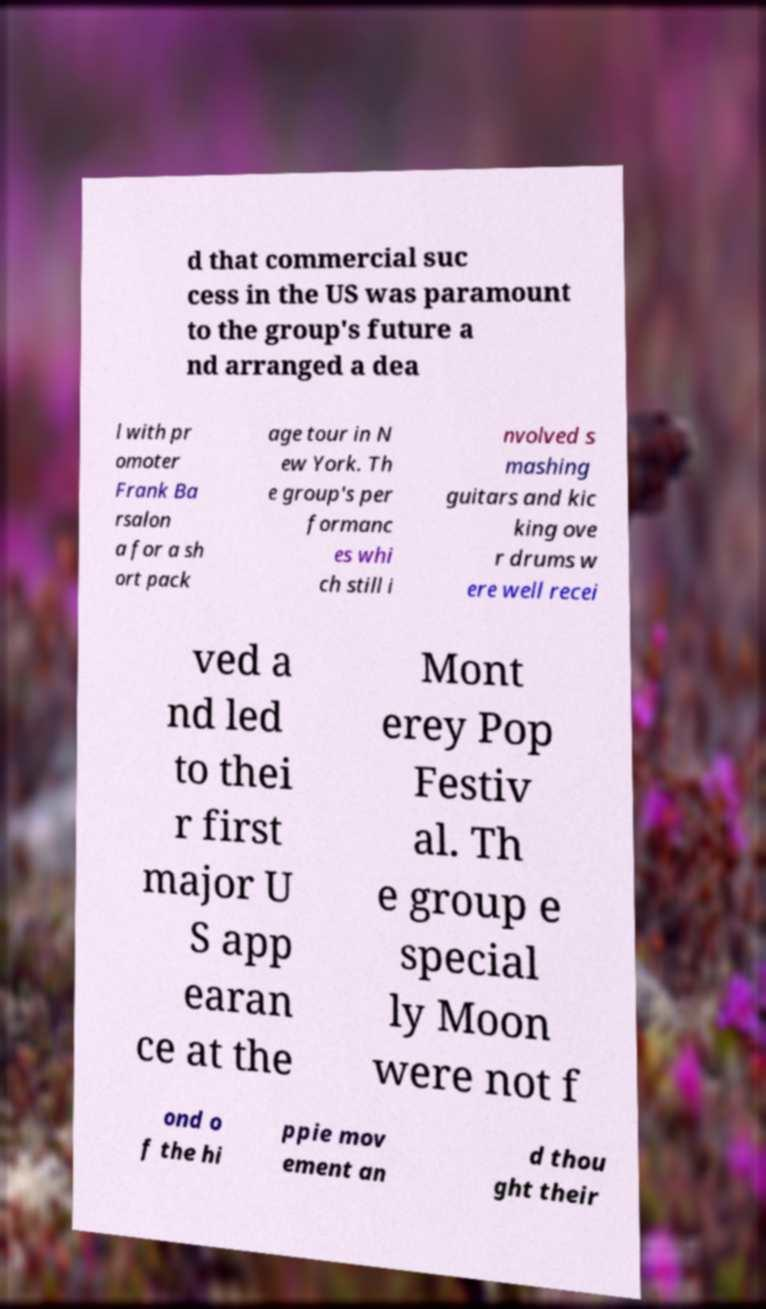Can you accurately transcribe the text from the provided image for me? d that commercial suc cess in the US was paramount to the group's future a nd arranged a dea l with pr omoter Frank Ba rsalon a for a sh ort pack age tour in N ew York. Th e group's per formanc es whi ch still i nvolved s mashing guitars and kic king ove r drums w ere well recei ved a nd led to thei r first major U S app earan ce at the Mont erey Pop Festiv al. Th e group e special ly Moon were not f ond o f the hi ppie mov ement an d thou ght their 